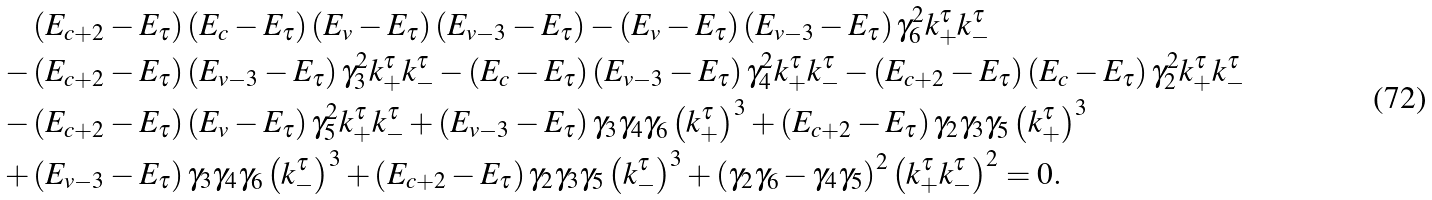<formula> <loc_0><loc_0><loc_500><loc_500>& \left ( E _ { c + 2 } - E _ { \tau } \right ) \left ( E _ { c } - E _ { \tau } \right ) \left ( E _ { v } - E _ { \tau } \right ) \left ( E _ { v - 3 } - E _ { \tau } \right ) - \left ( E _ { v } - E _ { \tau } \right ) \left ( E _ { v - 3 } - E _ { \tau } \right ) \gamma ^ { 2 } _ { 6 } k ^ { \tau } _ { + } k ^ { \tau } _ { - } \\ - & \left ( E _ { c + 2 } - E _ { \tau } \right ) \left ( E _ { v - 3 } - E _ { \tau } \right ) \gamma ^ { 2 } _ { 3 } k ^ { \tau } _ { + } k ^ { \tau } _ { - } - \left ( E _ { c } - E _ { \tau } \right ) \left ( E _ { v - 3 } - E _ { \tau } \right ) \gamma ^ { 2 } _ { 4 } k ^ { \tau } _ { + } k ^ { \tau } _ { - } - \left ( E _ { c + 2 } - E _ { \tau } \right ) \left ( E _ { c } - E _ { \tau } \right ) \gamma ^ { 2 } _ { 2 } k ^ { \tau } _ { + } k ^ { \tau } _ { - } \\ - & \left ( E _ { c + 2 } - E _ { \tau } \right ) \left ( E _ { v } - E _ { \tau } \right ) \gamma ^ { 2 } _ { 5 } k ^ { \tau } _ { + } k ^ { \tau } _ { - } + \left ( E _ { v - 3 } - E _ { \tau } \right ) \gamma _ { 3 } \gamma _ { 4 } \gamma _ { 6 } \left ( k ^ { \tau } _ { + } \right ) ^ { 3 } + \left ( E _ { c + 2 } - E _ { \tau } \right ) \gamma _ { 2 } \gamma _ { 3 } \gamma _ { 5 } \left ( k ^ { \tau } _ { + } \right ) ^ { 3 } \\ + & \left ( E _ { v - 3 } - E _ { \tau } \right ) \gamma _ { 3 } \gamma _ { 4 } \gamma _ { 6 } \left ( k ^ { \tau } _ { - } \right ) ^ { 3 } + \left ( E _ { c + 2 } - E _ { \tau } \right ) \gamma _ { 2 } \gamma _ { 3 } \gamma _ { 5 } \left ( k ^ { \tau } _ { - } \right ) ^ { 3 } + \left ( \gamma _ { 2 } \gamma _ { 6 } - \gamma _ { 4 } \gamma _ { 5 } \right ) ^ { 2 } \left ( k ^ { \tau } _ { + } k ^ { \tau } _ { - } \right ) ^ { 2 } = 0 .</formula> 